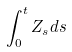Convert formula to latex. <formula><loc_0><loc_0><loc_500><loc_500>\int _ { 0 } ^ { t } Z _ { s } d s</formula> 